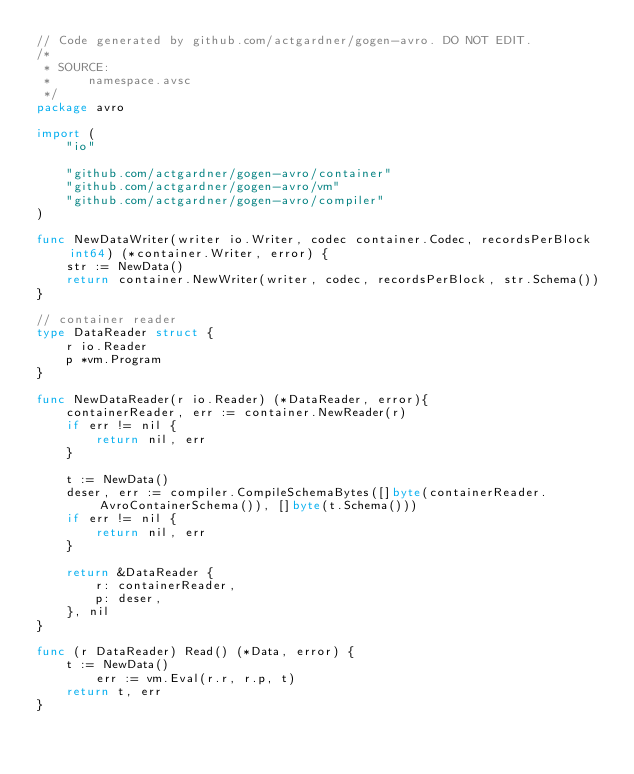Convert code to text. <code><loc_0><loc_0><loc_500><loc_500><_Go_>// Code generated by github.com/actgardner/gogen-avro. DO NOT EDIT.
/*
 * SOURCE:
 *     namespace.avsc
 */
package avro

import (
	"io"

	"github.com/actgardner/gogen-avro/container"
	"github.com/actgardner/gogen-avro/vm"
	"github.com/actgardner/gogen-avro/compiler"
)

func NewDataWriter(writer io.Writer, codec container.Codec, recordsPerBlock int64) (*container.Writer, error) {
	str := NewData()
	return container.NewWriter(writer, codec, recordsPerBlock, str.Schema())
}

// container reader
type DataReader struct {
	r io.Reader
	p *vm.Program
}

func NewDataReader(r io.Reader) (*DataReader, error){
	containerReader, err := container.NewReader(r)
	if err != nil {
		return nil, err
	}

	t := NewData()
	deser, err := compiler.CompileSchemaBytes([]byte(containerReader.AvroContainerSchema()), []byte(t.Schema()))
	if err != nil {
		return nil, err
	}

	return &DataReader {
		r: containerReader,
		p: deser,
	}, nil
}

func (r DataReader) Read() (*Data, error) {
	t := NewData()
        err := vm.Eval(r.r, r.p, t)
	return t, err
}
</code> 